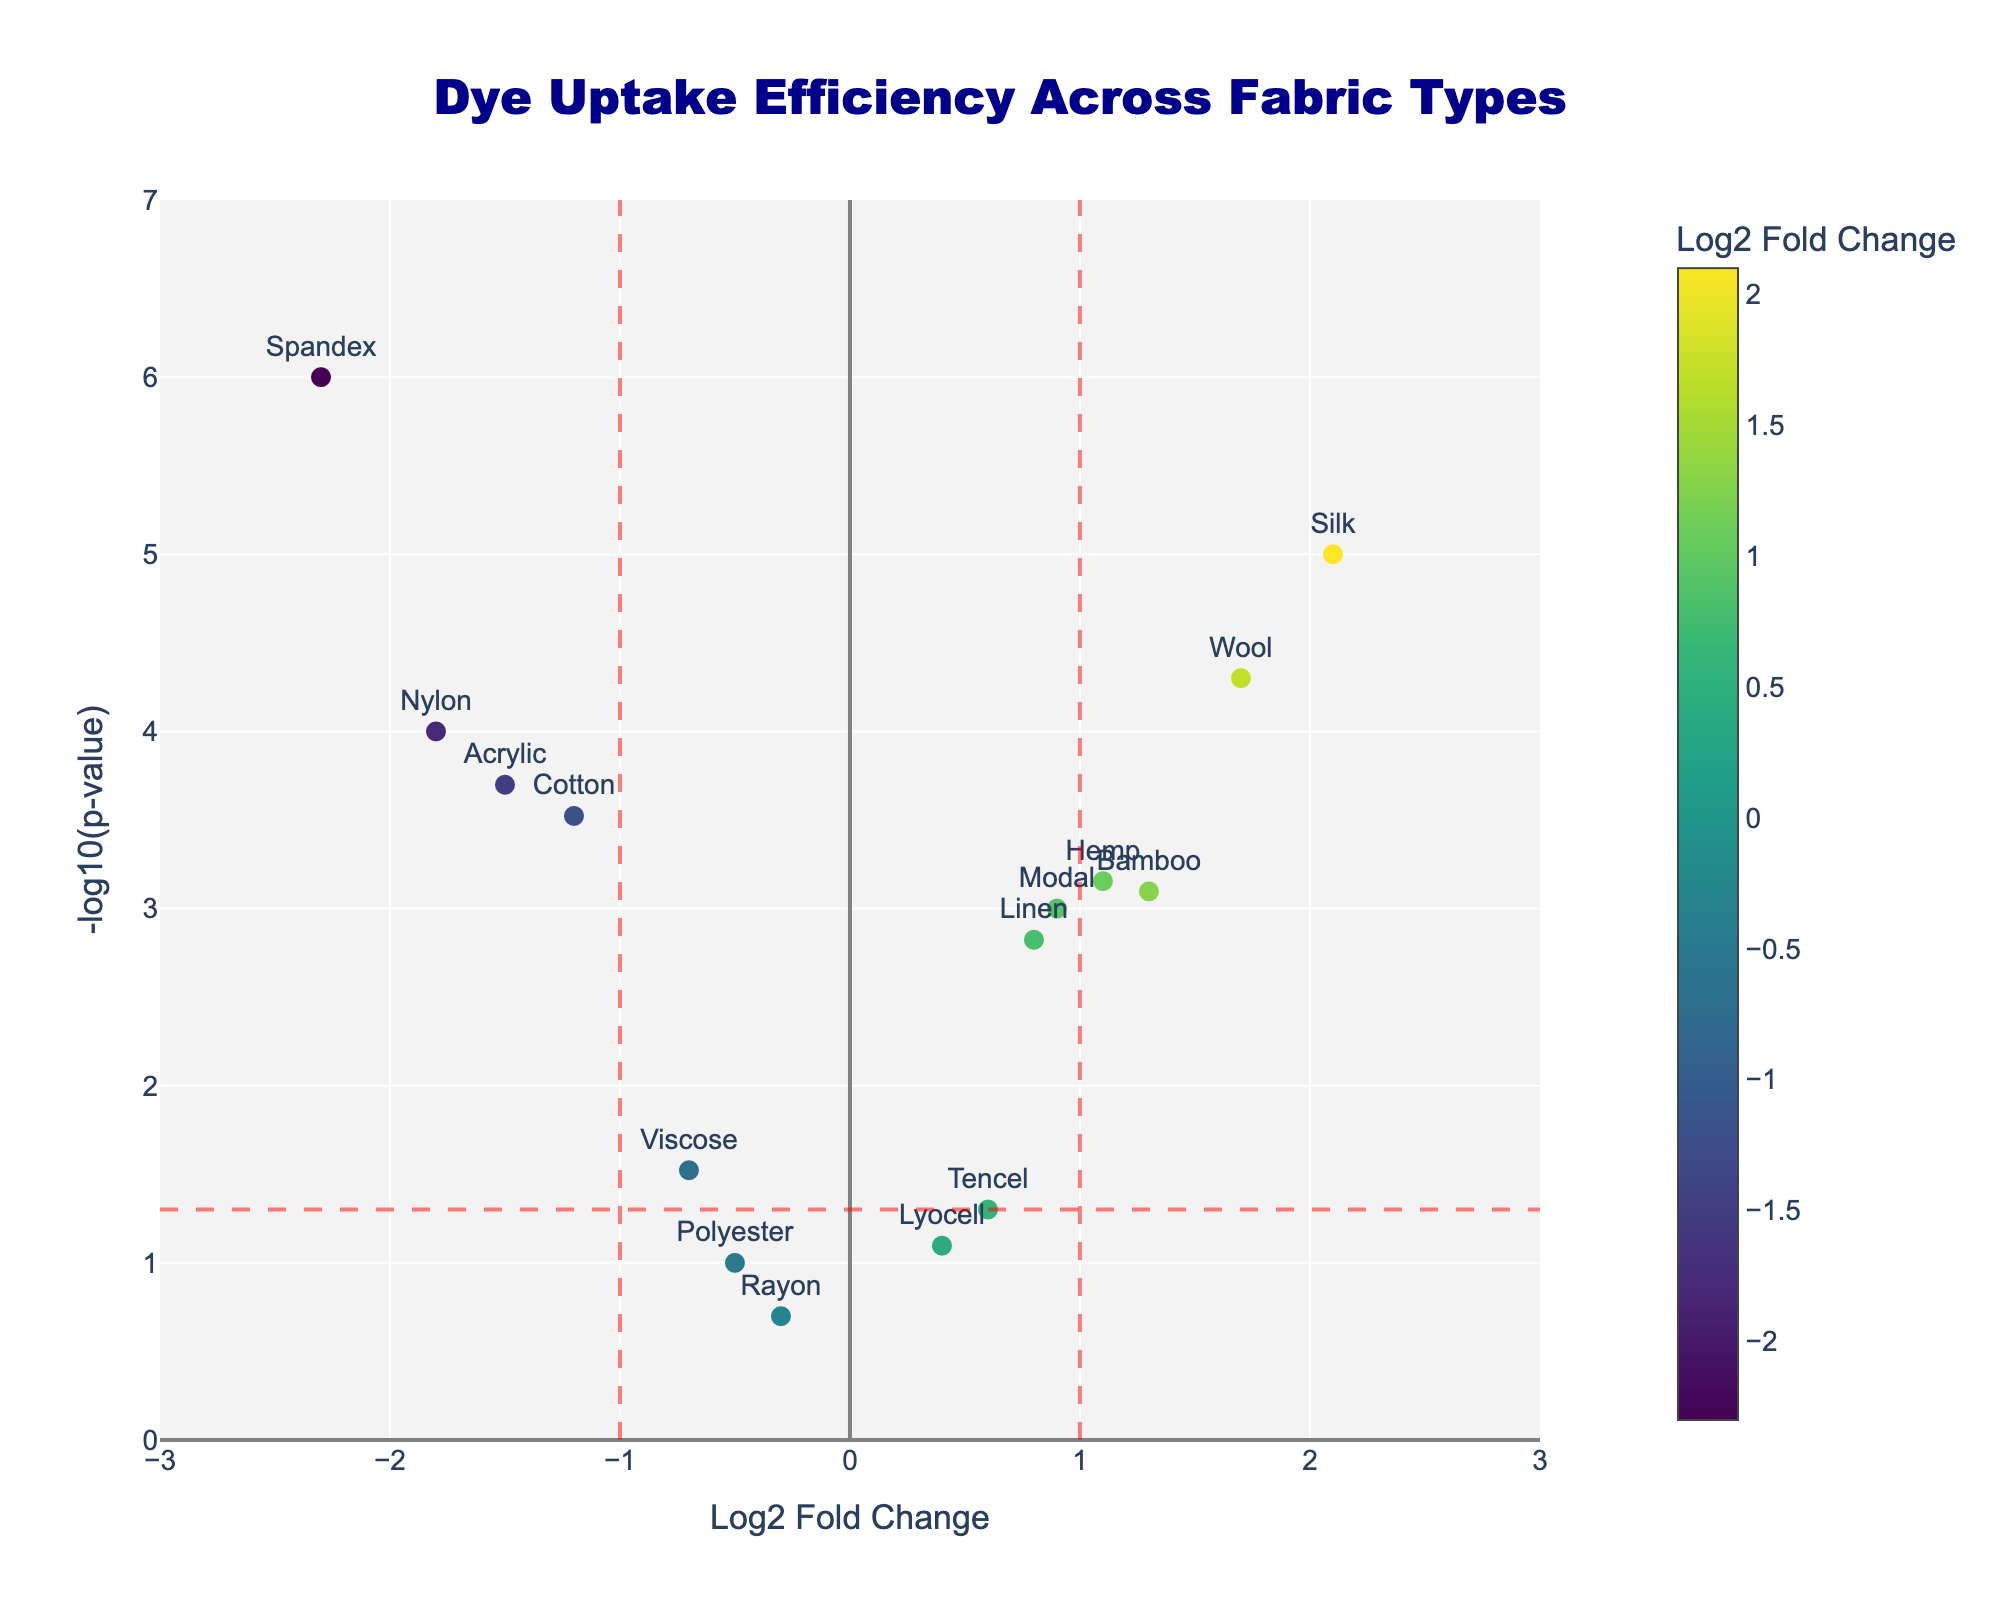What is the title of the figure? The title of the figure can be found at the top of the graph, it's usually placed centrally. In this case, it reads "Dye Uptake Efficiency Across Fabric Types".
Answer: Dye Uptake Efficiency Across Fabric Types Which fabric has the highest dye uptake efficiency? The fabric with the highest dye uptake efficiency can be identified by locating the data point with the maximum Log2 Fold Change on the x-axis. This is represented by Silk at a Log2FoldChange of 2.1.
Answer: Silk Which fabric has the lowest p-value? To find the fabric with the lowest p-value, we need to look at the highest point on the y-axis since it represents -log10(p-value). The highest point belongs to Spandex.
Answer: Spandex How many fabrics have a Log2 Fold Change greater than 1? We count the data points to the right of the vertical line at x=1. These points are for Silk, Wool, Bamboo, Hemp, and Modal. This gives us a count of 5 fabrics.
Answer: 5 Which fabric is the least significant in terms of p-value and has Log2 Fold Change less than 0? The least significant in terms of p-value means having a lower value on the y-axis. For fabrics with Log2 Fold Change less than 0, the one closest to the x-axis is Rayon.
Answer: Rayon What is the -log10(p-value) of the fabric with the highest Log2 Fold Change? First, find the fabric with the highest Log2 Fold Change, which is Silk. Then, check the y-value which represents -log10(p-value) for Silk. This value is approximately 5.
Answer: ~5 Compare the dye uptake efficiency between Cotton and Nylon. Which fabric has higher fold change? Find both Cotton and Nylon on the x-axis, noting their Log2 Fold Change values. Cotton has -1.2 and Nylon has -1.8. Since -1.2 is greater than -1.8, Cotton has a higher fold change.
Answer: Cotton Which fabrics are considered significantly different in terms of p-value with a fold change between -1 and 1? Significant fabrics have a -log10(p-value) higher than the horizontal line representing 0.05 (significance threshold). Check for fabrics within -1 and 1 on the x-axis: Linen, Bamboo, Tencel, Modal, Hemp. Filter out those with p-values that are not significant: Linen, Bamboo, Modal, Hemp.
Answer: Linen, Bamboo, Modal, Hemp Which fabric has the lowest Log2 Fold Change? The fabric with the lowest Log2 Fold Change is found at the far left on the x-axis. Spandex is the fabric with the lowest Log2 Fold Change of -2.3.
Answer: Spandex 